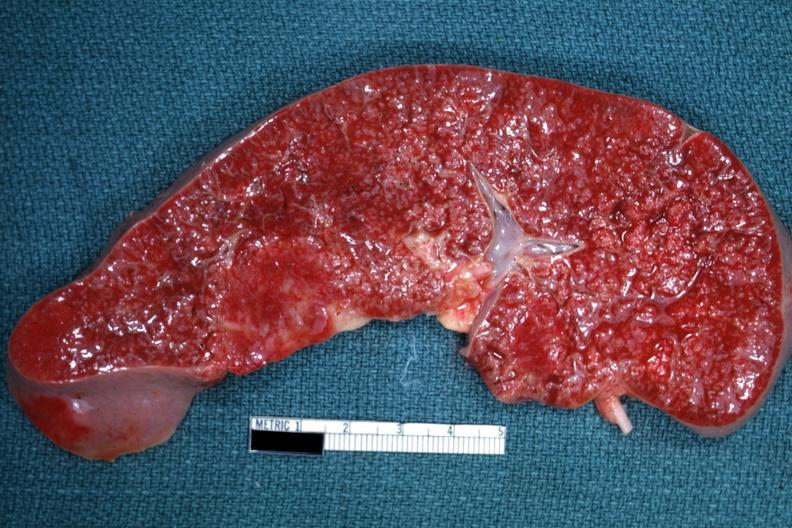s granulomata diagnosed as reticulum cell sarcoma?
Answer the question using a single word or phrase. Yes 